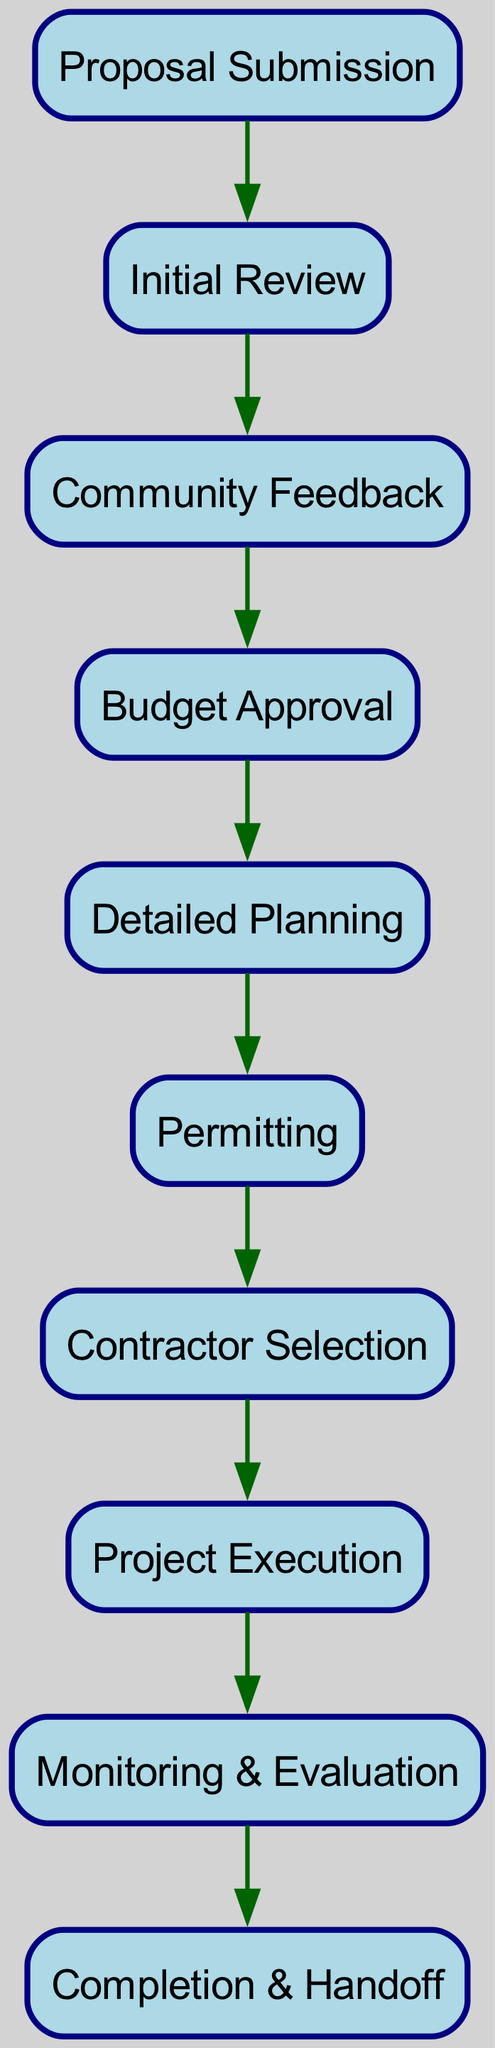What is the starting point of the workflow? The first node in the directed graph represents the starting point of the workflow, which is "Proposal Submission."
Answer: Proposal Submission What follows after "Initial Review"? After "Initial Review," the directed edge leads to "Community Feedback," which indicates the next step in the workflow.
Answer: Community Feedback How many total nodes are in the diagram? By counting each unique node in the diagram, we find that there are ten nodes representing different stages of the workflow.
Answer: 10 What is the last step in the project workflow? The final node in the directed graph indicates the last step of the workflow, which is "Completion & Handoff."
Answer: Completion & Handoff Which step comes immediately after "Budget Approval"? The node that follows "Budget Approval" is "Detailed Planning," as indicated by the directed edge from "Budget Approval" to "Detailed Planning."
Answer: Detailed Planning What is the total number of edges in the diagram? The diagram contains directed edges that connect the nodes; by counting them, we determine that there are nine edges in total.
Answer: 9 What is the relationship between "Project Execution" and "Monitoring & Evaluation"? There is a direct edge leading from "Project Execution" to "Monitoring & Evaluation," indicating that the latter is the subsequent step after the former within the workflow.
Answer: Monitoring & Evaluation How many steps are there from "Proposal Submission" to "Contractor Selection"? By following the edges from "Proposal Submission," we can trace through five steps to reach "Contractor Selection": Proposal Submission → Initial Review → Community Feedback → Budget Approval → Detailed Planning → Permitting → Contractor Selection.
Answer: 5 steps Is "Permitting" before or after "Detailed Planning"? Referring to the directed edges, "Permitting" follows "Detailed Planning," which means it comes after that step in the workflow.
Answer: After 